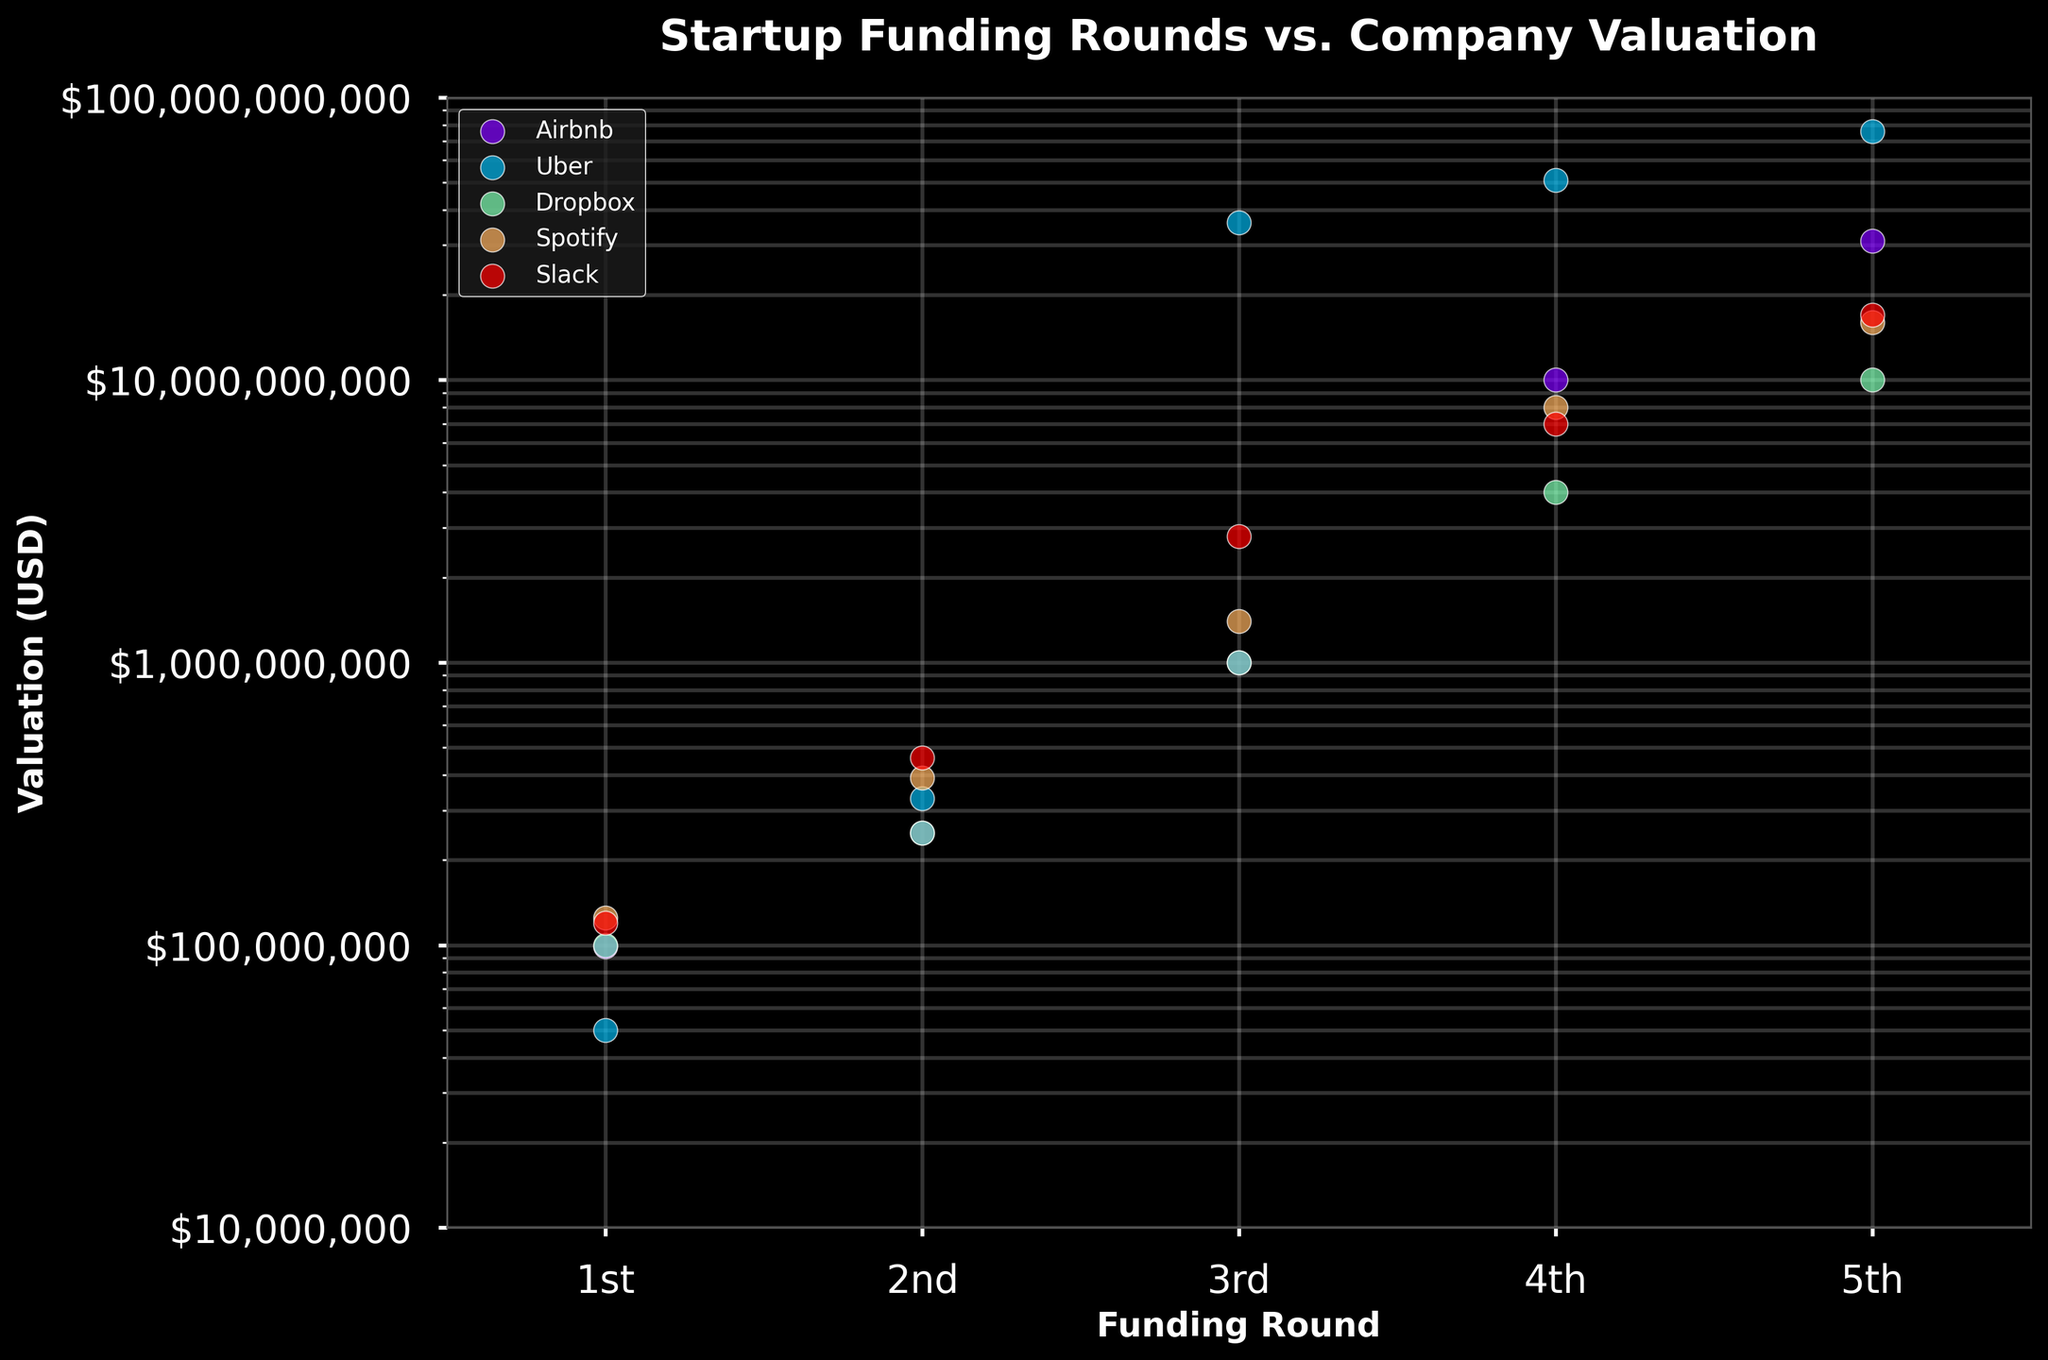How many companies are shown in the figure? The plot shows different sets of data points for each company, and the legend lists the names of the companies. By counting the distinct labels/colors in the legend, we can determine the number of companies.
Answer: 5 Which company has the highest valuation in the 3rd funding round? To find the highest valuation for the 3rd funding round, locate the x-axis label for the 3rd round and then find the point with the highest y-value. Compare the valuations of all companies for the 3rd round.
Answer: Uber What's the average valuation of Dropbox across all funding rounds? To calculate the average valuation, sum the valuations for Dropbox across all rounds, and then divide by the number of rounds. Valuations are: $100M, $250M, $1B, $4B, $10B. The sum is $15.35B, so the average is $15.35B / 5 = $3.07B.
Answer: $3.07B Which company shows the most significant growth in valuation from the 1st to the 5th funding round? To determine which company has the largest growth, subtract the 1st funding round valuation from the 5th round valuation for each company and compare the differences. Airbnb: $31B - $99M, Uber: $76B - $50M, Dropbox: $10B - $100M, Spotify: $16B - $125M, Slack: $17B - $120M. Uber has the largest difference.
Answer: Uber What trend is visible for the valuation of Spotify as the funding rounds increase? By observing the plot, the valuations of Spotify are plotted against the funding rounds. Reading from the 1st to the 5th funding round, note how the y-values change. Spotify's valuation increases steadily with each funding round.
Answer: Increasing Which two companies have similar valuations in the 4th funding round? Look at the valuations of all companies for the 4th funding round and identify which two companies have points that are closest in y-value. Spotify and Slack have similar valuations in the 4th funding round.
Answer: Spotify and Slack Is there any company whose valuation decreases in any round? To check for decreases, examine each company's valuations across consecutive funding rounds. No company's valuation decreases between any funding rounds; all valuations increase or stay the same.
Answer: No How does Uber's valuation compare to Airbnb's in the 5th funding round? Compare the y-values for Uber and Airbnb specifically in the 5th funding round. Uber's valuation is higher than Airbnb's in the 5th round.
Answer: Higher What is the approximate valuation range for the companies in the 2nd funding round? Identify the lowest and highest y-values for the 2nd funding round across all companies. The range spans from Airbnb at $250M to Uber at $330M.
Answer: $250M - $330M 